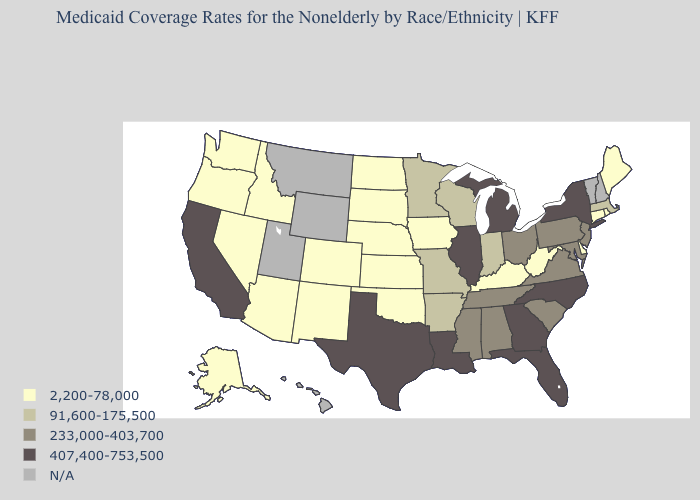Name the states that have a value in the range N/A?
Concise answer only. Hawaii, Montana, New Hampshire, Utah, Vermont, Wyoming. What is the lowest value in the USA?
Short answer required. 2,200-78,000. Which states have the highest value in the USA?
Short answer required. California, Florida, Georgia, Illinois, Louisiana, Michigan, New York, North Carolina, Texas. What is the value of New Jersey?
Answer briefly. 233,000-403,700. Name the states that have a value in the range 233,000-403,700?
Quick response, please. Alabama, Maryland, Mississippi, New Jersey, Ohio, Pennsylvania, South Carolina, Tennessee, Virginia. What is the lowest value in the West?
Write a very short answer. 2,200-78,000. Name the states that have a value in the range 2,200-78,000?
Give a very brief answer. Alaska, Arizona, Colorado, Connecticut, Delaware, Idaho, Iowa, Kansas, Kentucky, Maine, Nebraska, Nevada, New Mexico, North Dakota, Oklahoma, Oregon, Rhode Island, South Dakota, Washington, West Virginia. What is the value of Nevada?
Give a very brief answer. 2,200-78,000. Does Illinois have the highest value in the USA?
Keep it brief. Yes. Among the states that border Wisconsin , which have the highest value?
Quick response, please. Illinois, Michigan. Among the states that border Arkansas , does Missouri have the highest value?
Write a very short answer. No. Does the map have missing data?
Short answer required. Yes. What is the value of Louisiana?
Concise answer only. 407,400-753,500. 